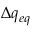Convert formula to latex. <formula><loc_0><loc_0><loc_500><loc_500>\Delta q _ { e q }</formula> 